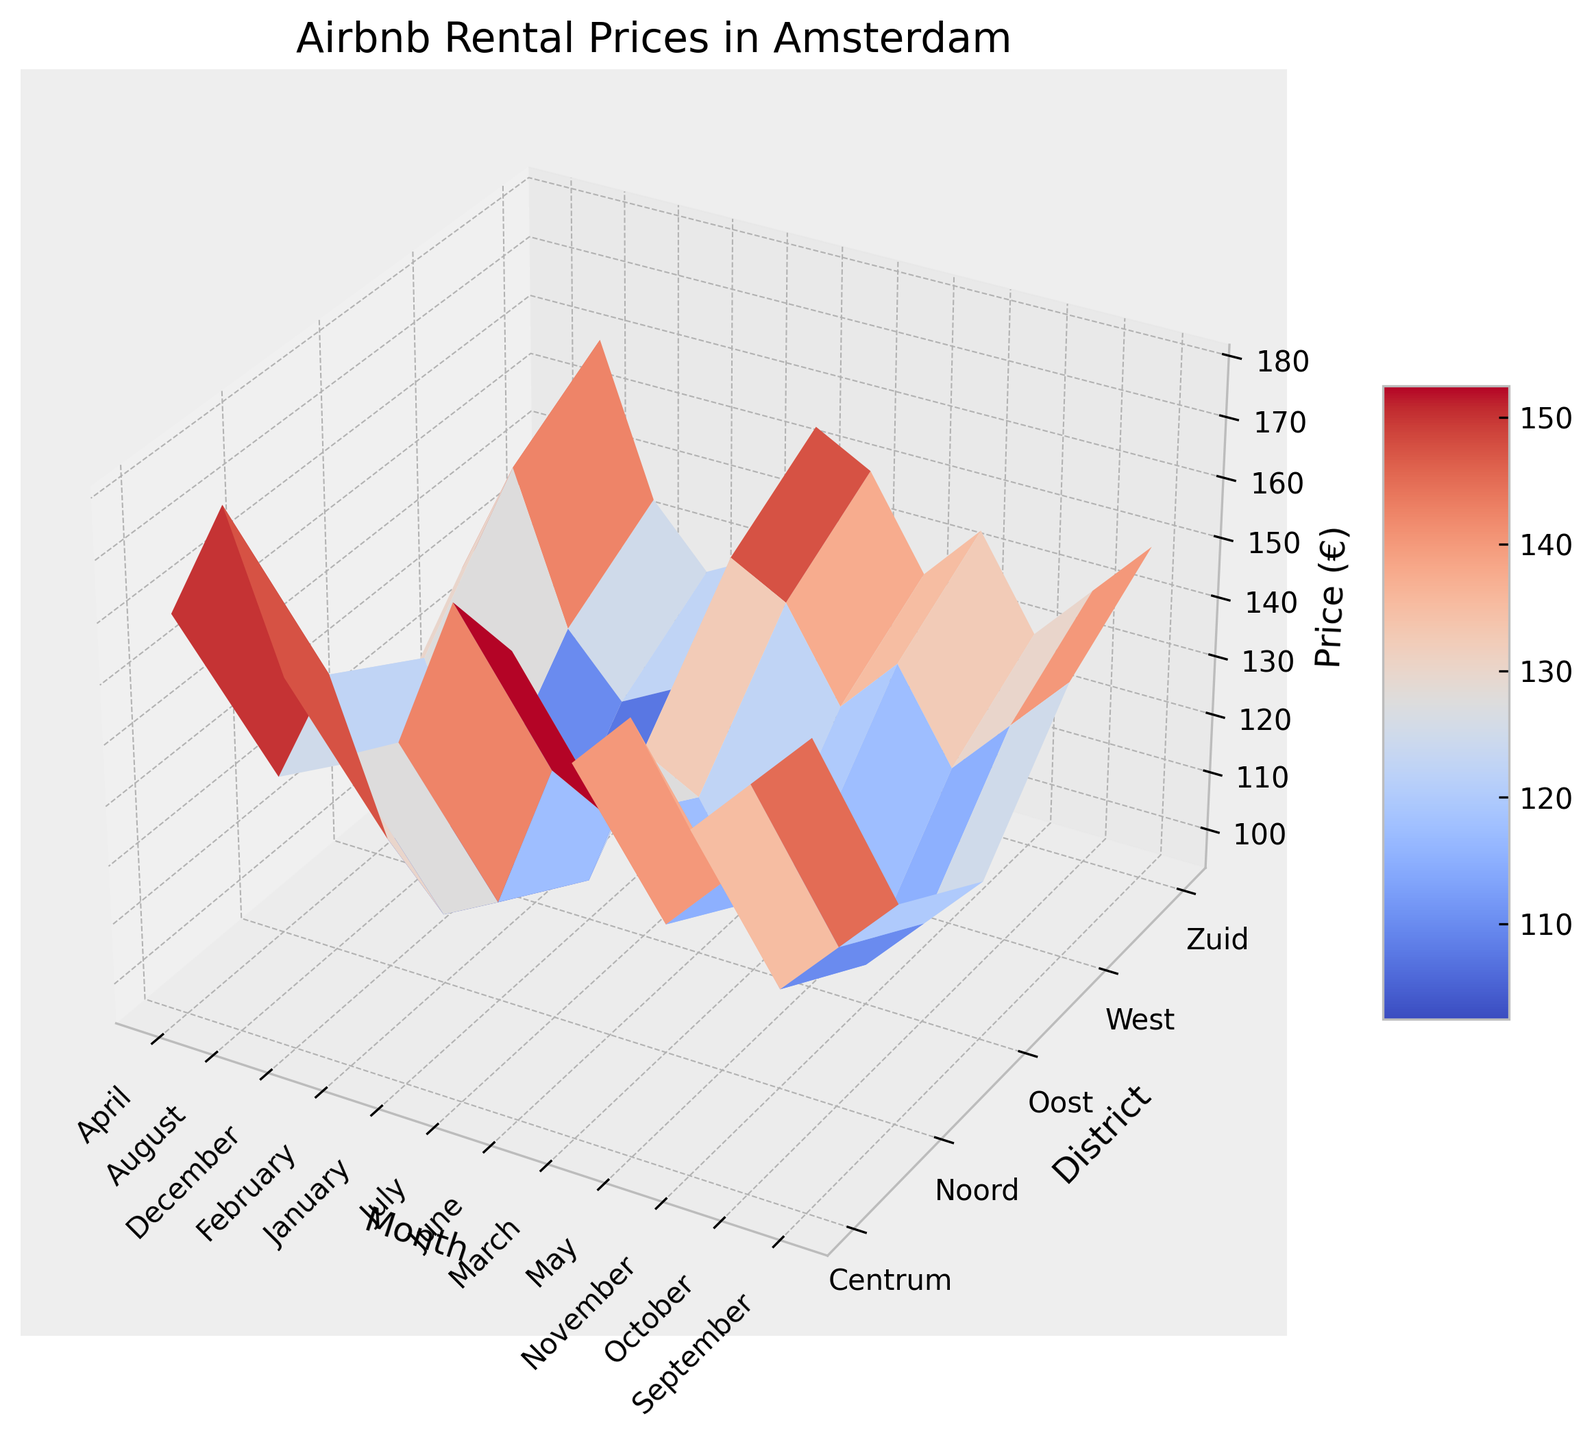Which district has the highest rental price in August? Look at the bar heights for each district in August. Centrum has the highest bar, indicating the highest rental price.
Answer: Centrum Which month shows the highest rental prices across all districts? Observe which column (representing months) has the highest bars on average. August has the highest average price across districts.
Answer: August What is the difference in rental price between Centrum and Noord in July? Check the height of the bar for Centrum in July (175) and for Noord in July (135). Subtract Noord's price from Centrum's price (175 - 135 = 40).
Answer: 40 Which district has the lowest rental price in January, and what is that price? Identify the lowest bar in January's column. Oost has the lowest rental price in January (100).
Answer: Oost, 100 What is the average rental price in Zuid for Q1 (first quarter: January to March)? Sum the rental prices in Zuid for January, February, and March (130 + 125 + 135) and divide by 3. The average is (130 + 125 + 135) / 3 = 130.
Answer: 130 During which month is the rental price in West lower compared to the preceding month? Notice the trends in the West district, one notable drop is from August (150) to September (140).
Answer: September How does the rental price in Oost in December compare to October? Check the heights of the bars for Oost in December (105) and October (110). It is lower in December.
Answer: December is lower What is the rental price trend in Centrum over the year? Observe the changing heights of bars in Centrum from January to December. The price generally increases from January, peaks in August, and then slightly decreases towards December.
Answer: Rising to August, then falling If you choose to visit in May, which district offers the least expensive rental price? Find the lowest bar in May. Oost offers the least expensive rental price with a price of 115.
Answer: Oost What is the combined rental price of West in June and July? Sum the prices of West for June (140) and July (145). The combined price is 140 + 145 = 285.
Answer: 285 